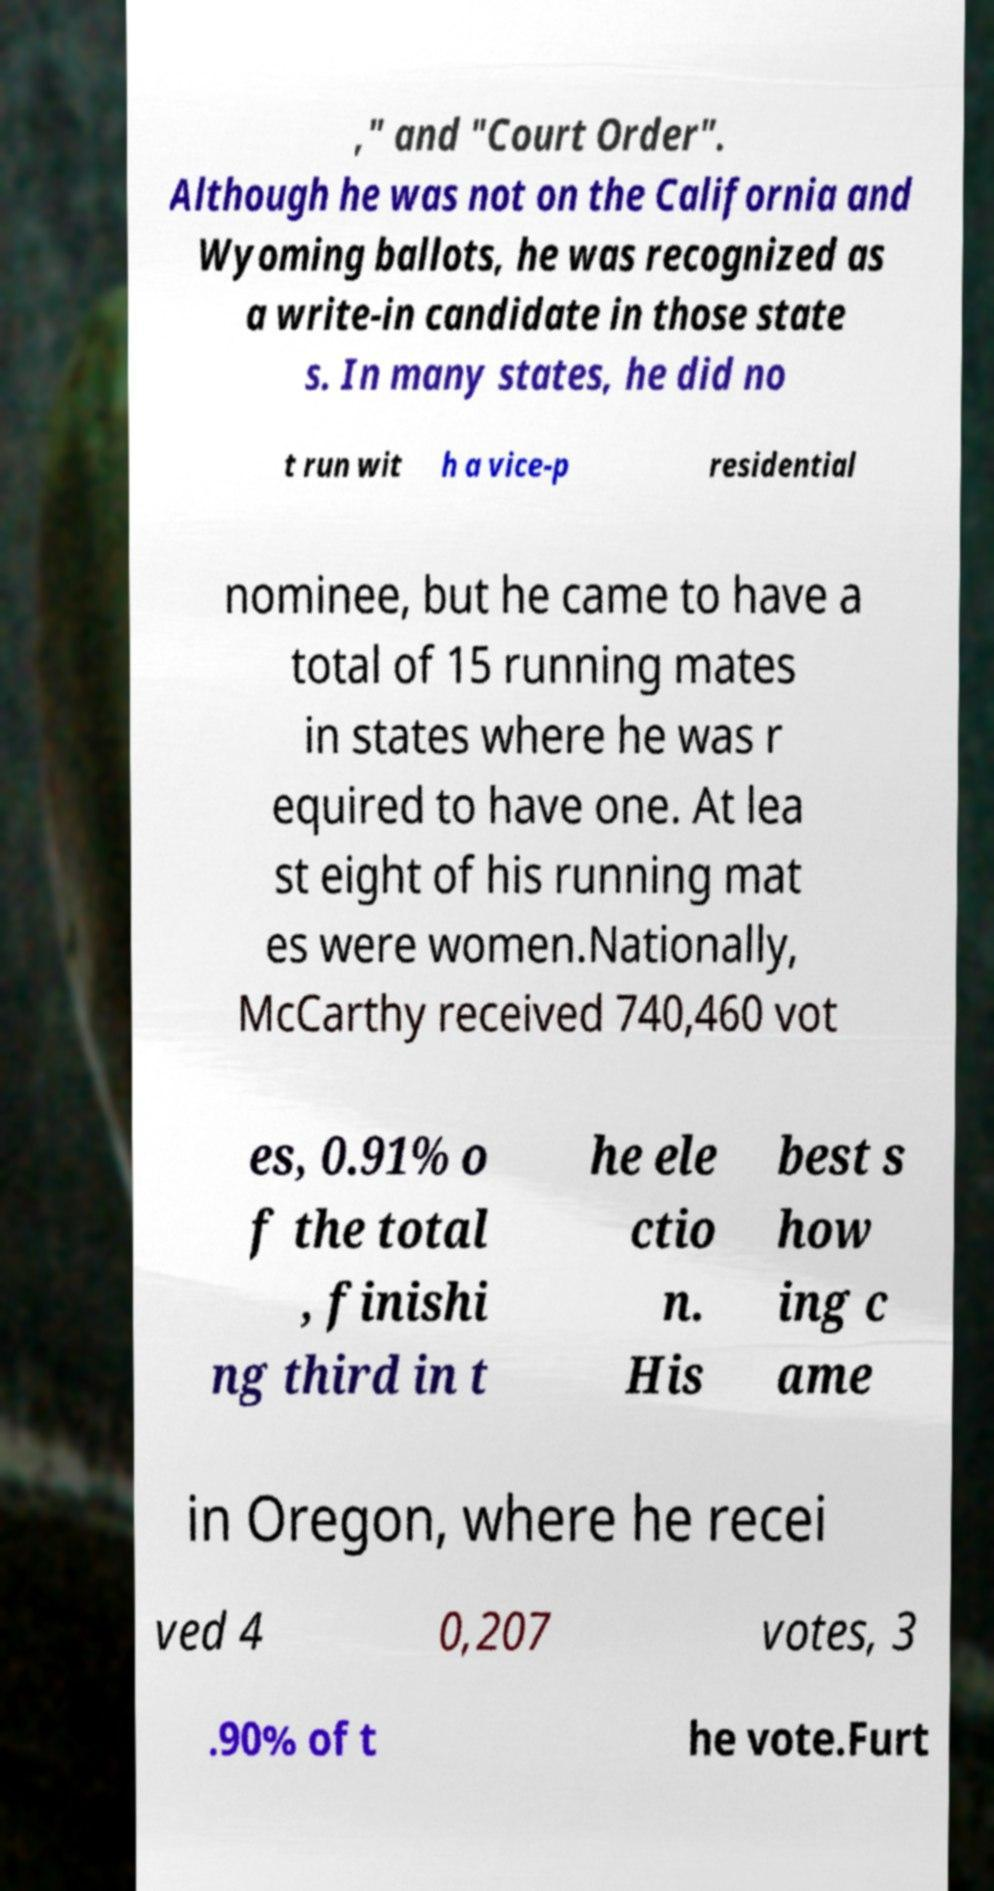What messages or text are displayed in this image? I need them in a readable, typed format. ," and "Court Order". Although he was not on the California and Wyoming ballots, he was recognized as a write-in candidate in those state s. In many states, he did no t run wit h a vice-p residential nominee, but he came to have a total of 15 running mates in states where he was r equired to have one. At lea st eight of his running mat es were women.Nationally, McCarthy received 740,460 vot es, 0.91% o f the total , finishi ng third in t he ele ctio n. His best s how ing c ame in Oregon, where he recei ved 4 0,207 votes, 3 .90% of t he vote.Furt 